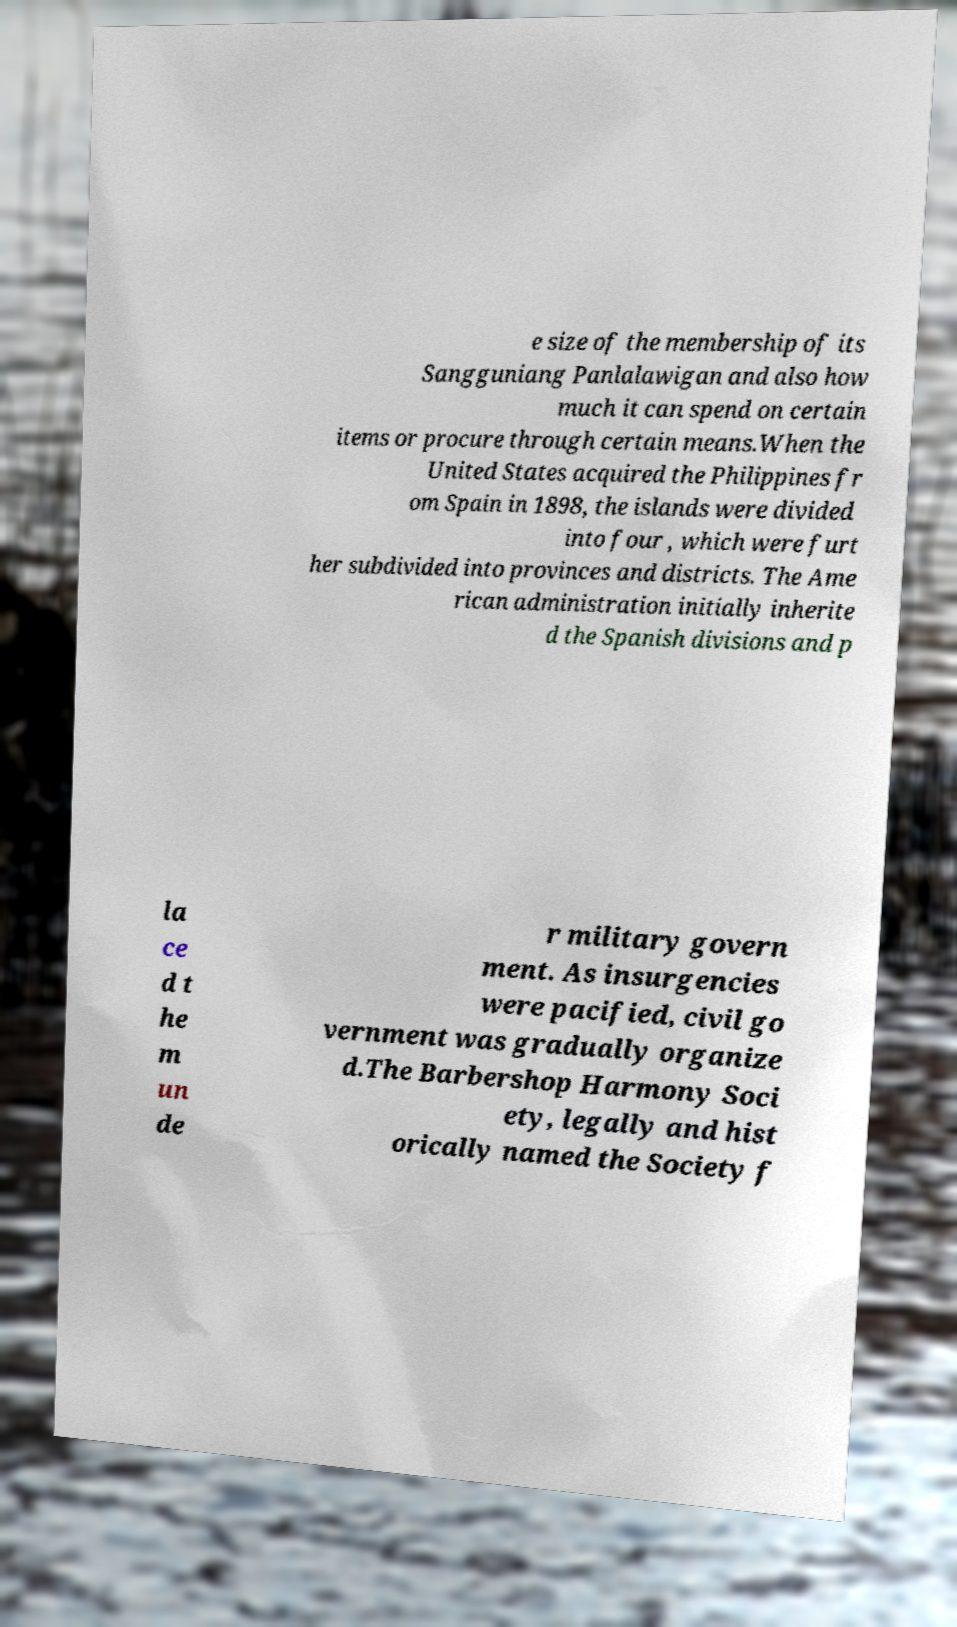Could you extract and type out the text from this image? e size of the membership of its Sangguniang Panlalawigan and also how much it can spend on certain items or procure through certain means.When the United States acquired the Philippines fr om Spain in 1898, the islands were divided into four , which were furt her subdivided into provinces and districts. The Ame rican administration initially inherite d the Spanish divisions and p la ce d t he m un de r military govern ment. As insurgencies were pacified, civil go vernment was gradually organize d.The Barbershop Harmony Soci ety, legally and hist orically named the Society f 